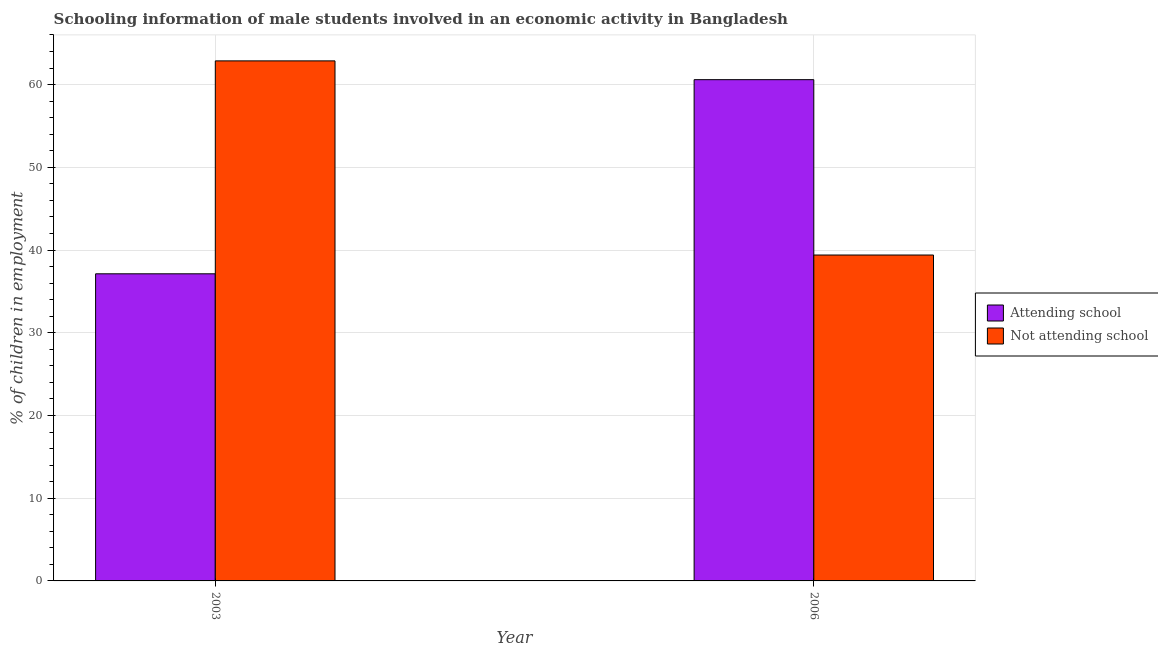How many different coloured bars are there?
Your response must be concise. 2. How many groups of bars are there?
Provide a succinct answer. 2. Are the number of bars per tick equal to the number of legend labels?
Offer a very short reply. Yes. Are the number of bars on each tick of the X-axis equal?
Offer a terse response. Yes. How many bars are there on the 1st tick from the right?
Ensure brevity in your answer.  2. What is the label of the 1st group of bars from the left?
Your answer should be compact. 2003. In how many cases, is the number of bars for a given year not equal to the number of legend labels?
Provide a short and direct response. 0. What is the percentage of employed males who are not attending school in 2003?
Give a very brief answer. 62.87. Across all years, what is the maximum percentage of employed males who are attending school?
Your answer should be compact. 60.6. Across all years, what is the minimum percentage of employed males who are not attending school?
Offer a terse response. 39.4. What is the total percentage of employed males who are not attending school in the graph?
Your answer should be very brief. 102.27. What is the difference between the percentage of employed males who are not attending school in 2003 and that in 2006?
Offer a terse response. 23.47. What is the difference between the percentage of employed males who are attending school in 2006 and the percentage of employed males who are not attending school in 2003?
Ensure brevity in your answer.  23.47. What is the average percentage of employed males who are attending school per year?
Provide a short and direct response. 48.86. In the year 2006, what is the difference between the percentage of employed males who are attending school and percentage of employed males who are not attending school?
Provide a short and direct response. 0. What is the ratio of the percentage of employed males who are attending school in 2003 to that in 2006?
Your answer should be compact. 0.61. What does the 1st bar from the left in 2003 represents?
Your answer should be very brief. Attending school. What does the 2nd bar from the right in 2003 represents?
Make the answer very short. Attending school. What is the difference between two consecutive major ticks on the Y-axis?
Provide a short and direct response. 10. Are the values on the major ticks of Y-axis written in scientific E-notation?
Your answer should be compact. No. Does the graph contain grids?
Your response must be concise. Yes. Where does the legend appear in the graph?
Offer a very short reply. Center right. How are the legend labels stacked?
Your answer should be very brief. Vertical. What is the title of the graph?
Offer a terse response. Schooling information of male students involved in an economic activity in Bangladesh. What is the label or title of the X-axis?
Provide a succinct answer. Year. What is the label or title of the Y-axis?
Give a very brief answer. % of children in employment. What is the % of children in employment in Attending school in 2003?
Give a very brief answer. 37.13. What is the % of children in employment of Not attending school in 2003?
Give a very brief answer. 62.87. What is the % of children in employment of Attending school in 2006?
Provide a short and direct response. 60.6. What is the % of children in employment of Not attending school in 2006?
Keep it short and to the point. 39.4. Across all years, what is the maximum % of children in employment of Attending school?
Offer a very short reply. 60.6. Across all years, what is the maximum % of children in employment of Not attending school?
Offer a very short reply. 62.87. Across all years, what is the minimum % of children in employment in Attending school?
Your answer should be compact. 37.13. Across all years, what is the minimum % of children in employment in Not attending school?
Your answer should be compact. 39.4. What is the total % of children in employment in Attending school in the graph?
Your response must be concise. 97.73. What is the total % of children in employment of Not attending school in the graph?
Offer a very short reply. 102.27. What is the difference between the % of children in employment in Attending school in 2003 and that in 2006?
Provide a short and direct response. -23.47. What is the difference between the % of children in employment in Not attending school in 2003 and that in 2006?
Keep it short and to the point. 23.47. What is the difference between the % of children in employment of Attending school in 2003 and the % of children in employment of Not attending school in 2006?
Ensure brevity in your answer.  -2.27. What is the average % of children in employment of Attending school per year?
Make the answer very short. 48.86. What is the average % of children in employment of Not attending school per year?
Offer a terse response. 51.14. In the year 2003, what is the difference between the % of children in employment of Attending school and % of children in employment of Not attending school?
Give a very brief answer. -25.74. In the year 2006, what is the difference between the % of children in employment in Attending school and % of children in employment in Not attending school?
Give a very brief answer. 21.2. What is the ratio of the % of children in employment in Attending school in 2003 to that in 2006?
Your answer should be very brief. 0.61. What is the ratio of the % of children in employment of Not attending school in 2003 to that in 2006?
Your answer should be very brief. 1.6. What is the difference between the highest and the second highest % of children in employment in Attending school?
Your response must be concise. 23.47. What is the difference between the highest and the second highest % of children in employment in Not attending school?
Offer a terse response. 23.47. What is the difference between the highest and the lowest % of children in employment of Attending school?
Your response must be concise. 23.47. What is the difference between the highest and the lowest % of children in employment in Not attending school?
Offer a terse response. 23.47. 